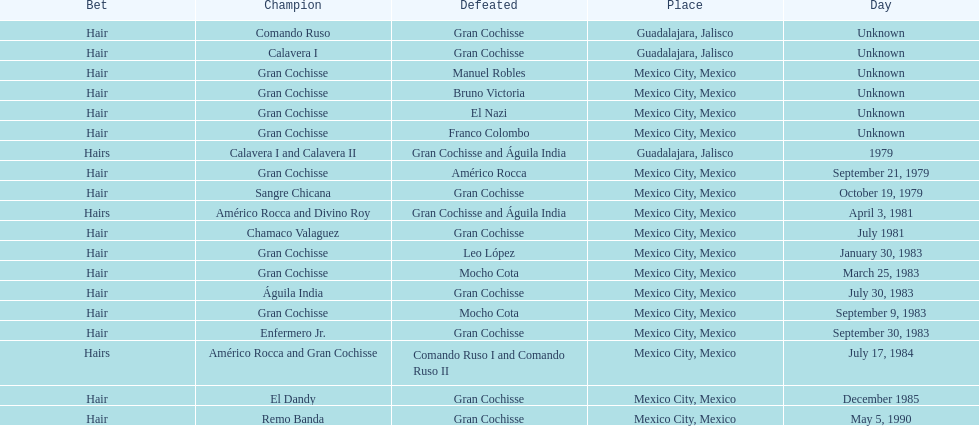When was gran chochisse first match that had a full date on record? September 21, 1979. 